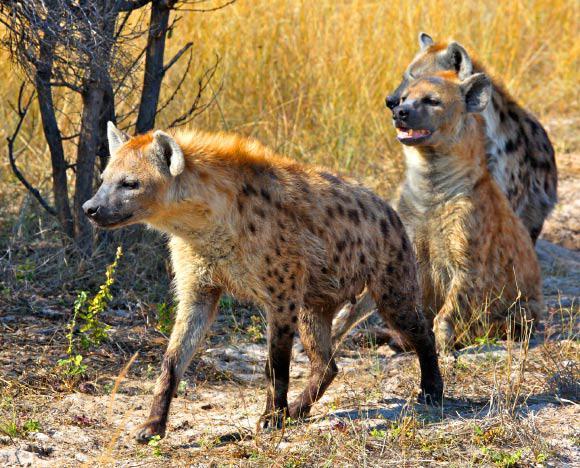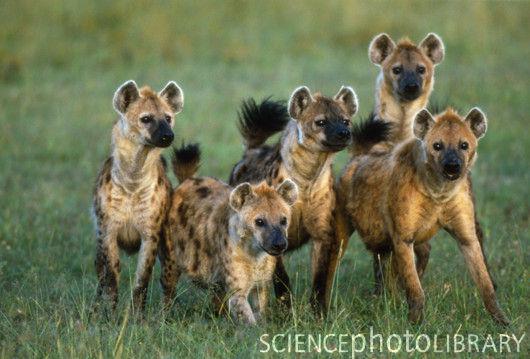The first image is the image on the left, the second image is the image on the right. Examine the images to the left and right. Is the description "An open-mouthed lion is near a hyena in one image." accurate? Answer yes or no. No. 